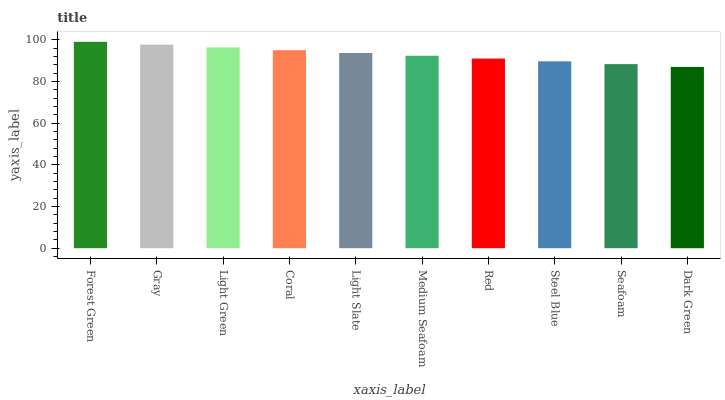Is Dark Green the minimum?
Answer yes or no. Yes. Is Forest Green the maximum?
Answer yes or no. Yes. Is Gray the minimum?
Answer yes or no. No. Is Gray the maximum?
Answer yes or no. No. Is Forest Green greater than Gray?
Answer yes or no. Yes. Is Gray less than Forest Green?
Answer yes or no. Yes. Is Gray greater than Forest Green?
Answer yes or no. No. Is Forest Green less than Gray?
Answer yes or no. No. Is Light Slate the high median?
Answer yes or no. Yes. Is Medium Seafoam the low median?
Answer yes or no. Yes. Is Red the high median?
Answer yes or no. No. Is Forest Green the low median?
Answer yes or no. No. 